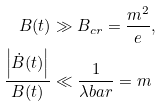Convert formula to latex. <formula><loc_0><loc_0><loc_500><loc_500>B ( t ) & \gg B _ { c r } = \frac { m ^ { 2 } } { e } , \\ \frac { \left | \dot { B } ( t ) \right | } { B ( t ) } & \ll \frac { 1 } { \lambda b a r } = m</formula> 